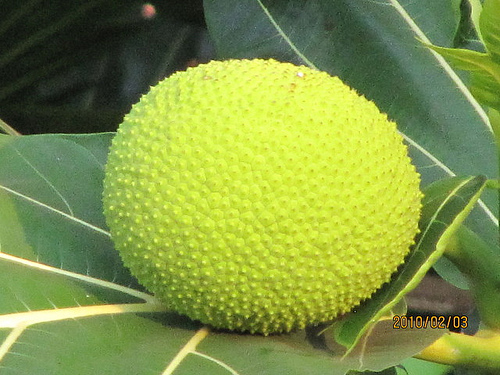<image>
Is the fruit to the left of the fruit? No. The fruit is not to the left of the fruit. From this viewpoint, they have a different horizontal relationship. 